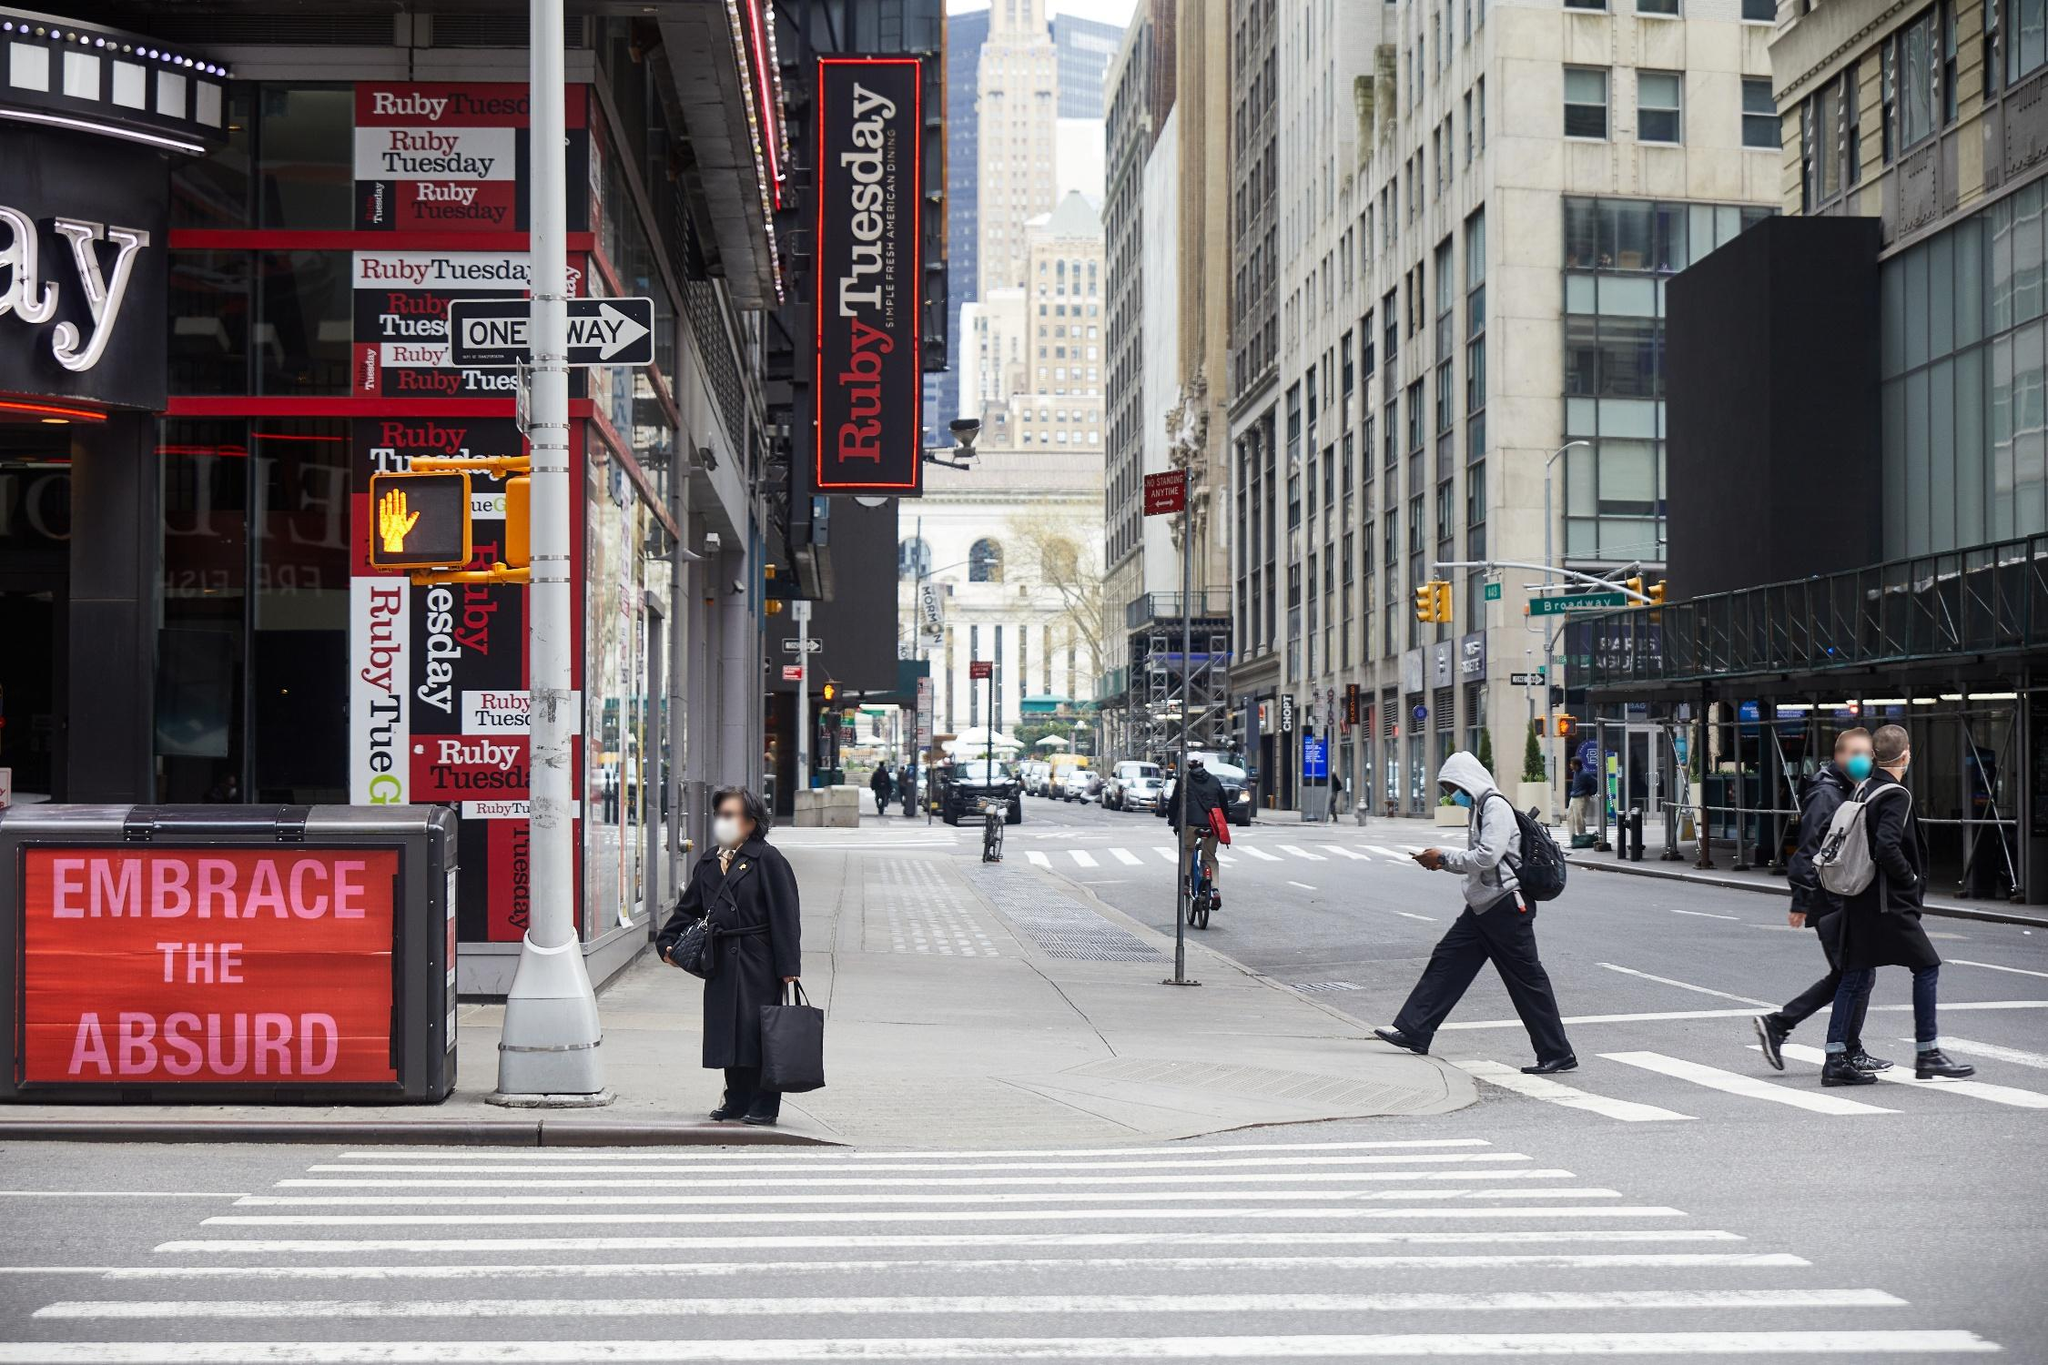Describe the atmosphere and mood of this scene. The image depicts a typical, bustling New York City atmosphere. Despite the general overcast sky, the scene is filled with the city’s usual energy and vibrancy. People are walking with purpose, some crossing the street and others standing at the corner waiting. The buildings’ tall and imposing presence adds a sense of grandeur, while the red ‘Ruby Tuesday’ signage injects a pop of color and liveliness. The street, though not overly crowded, displays the everyday rhythm and flow of life in the city. There is an intriguing juxtaposition of the calmness indicated by the muted lighting and the energetic movement of people, capturing the essence of urban life vividly. What can you infer about the people in the scene? The people captured in this scene appear to be engrossed in their daily activities. Despite the overcast weather, they seem to be moving with purpose. Some are crossing the street, while others are waiting for the pedestrian signal. Their attire suggests that they are prepared for a typical day in New York City, indicating a level of resilience and adaptability commonly found among city dwellers. The person in the foreground, standing alone and dressed in dark clothing, might be waiting to cross the street, reflecting a moment of stillness amidst the city's continual motion. 